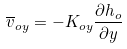Convert formula to latex. <formula><loc_0><loc_0><loc_500><loc_500>\overline { v } _ { o y } = - K _ { o y } \frac { \partial h _ { o } } { \partial y }</formula> 